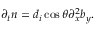Convert formula to latex. <formula><loc_0><loc_0><loc_500><loc_500>\partial _ { t } n = d _ { i } \cos \theta \partial _ { x } ^ { 2 } b _ { y } .</formula> 